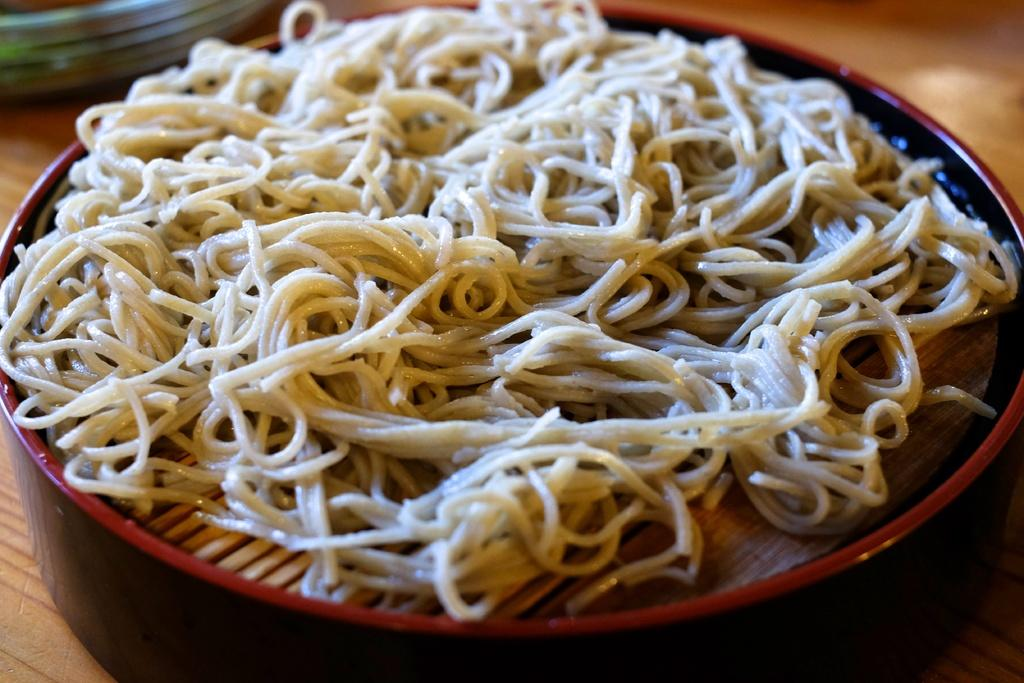What is in the bowl that is visible in the image? There is a bowl with food in the image. What else can be seen in the image besides the bowl of food? There are objects visible to the side of the bowl. What is the color of the surface on which the bowl and objects are placed? The objects are on a brown color surface. Is it raining in the image? There is no indication of rain in the image; it only shows a bowl with food and objects on a brown surface. 